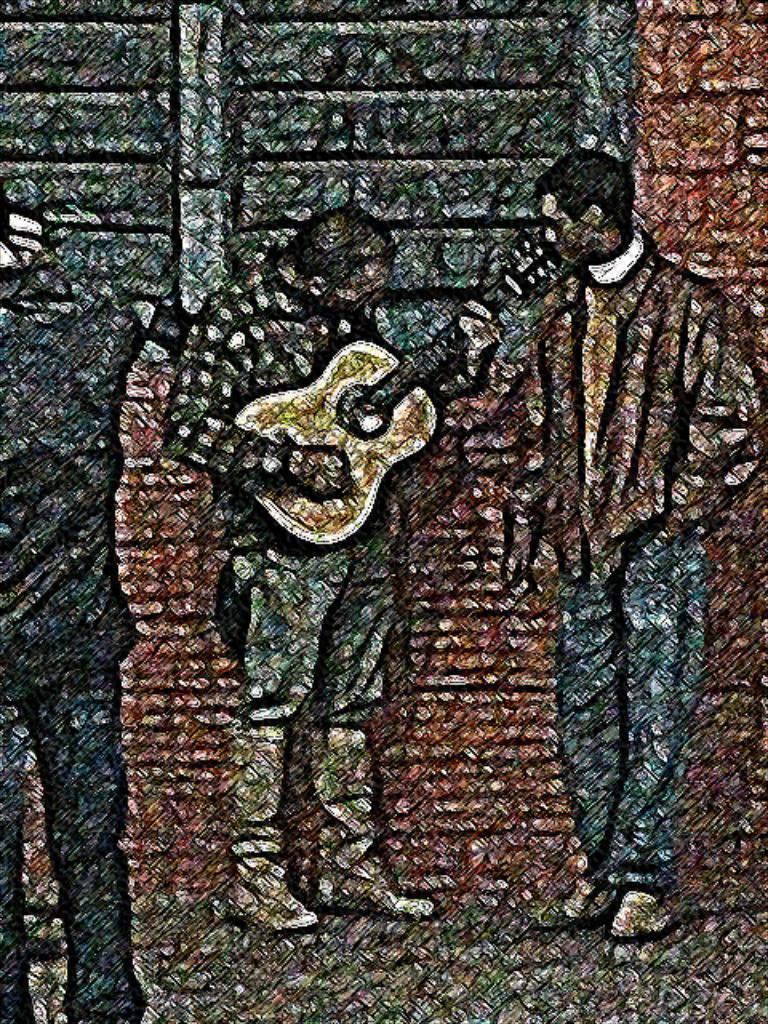In one or two sentences, can you explain what this image depicts? This is an art in this image in the center there is one man who is holding a guitar and playing. Beside him there is one person, and on the left side there is one person. In the background there is wall and windows, at the bottom there is a walkway. 